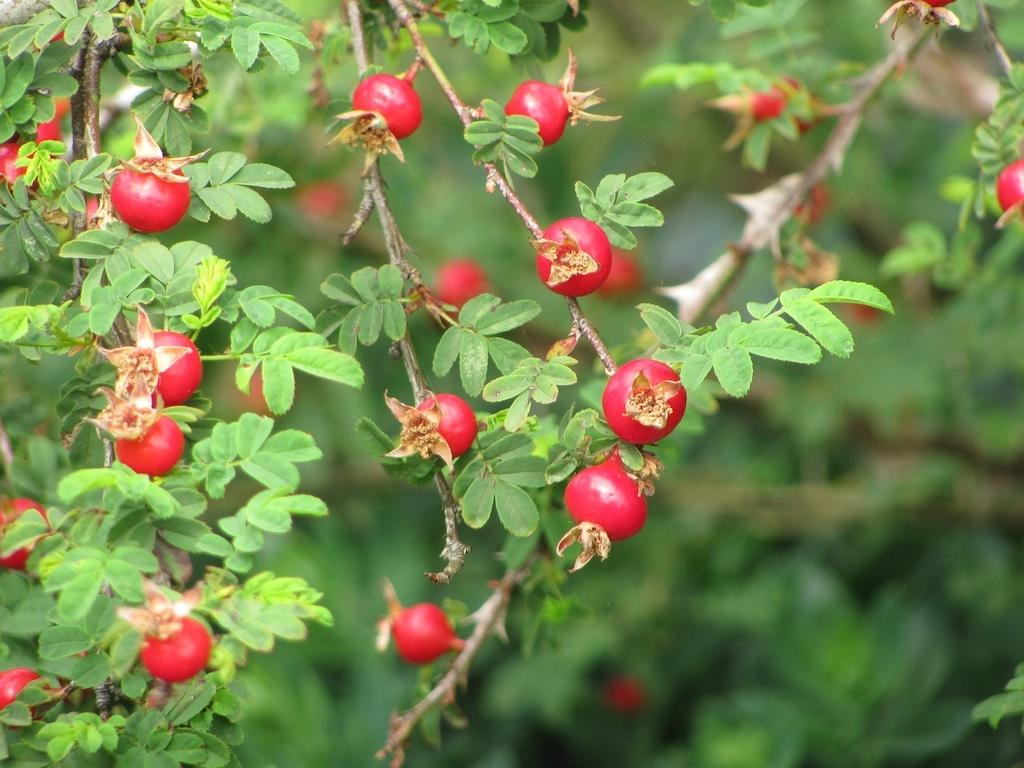What can be seen in the image that is related to plants? There are branches in the image. What are the characteristics of the branches? The branches have fruits and leaves. How would you describe the background of the image? The background of the image is blurry. What is causing the anger in the image? There is no indication of anger in the image; it features branches with fruits and leaves against a blurry background. 